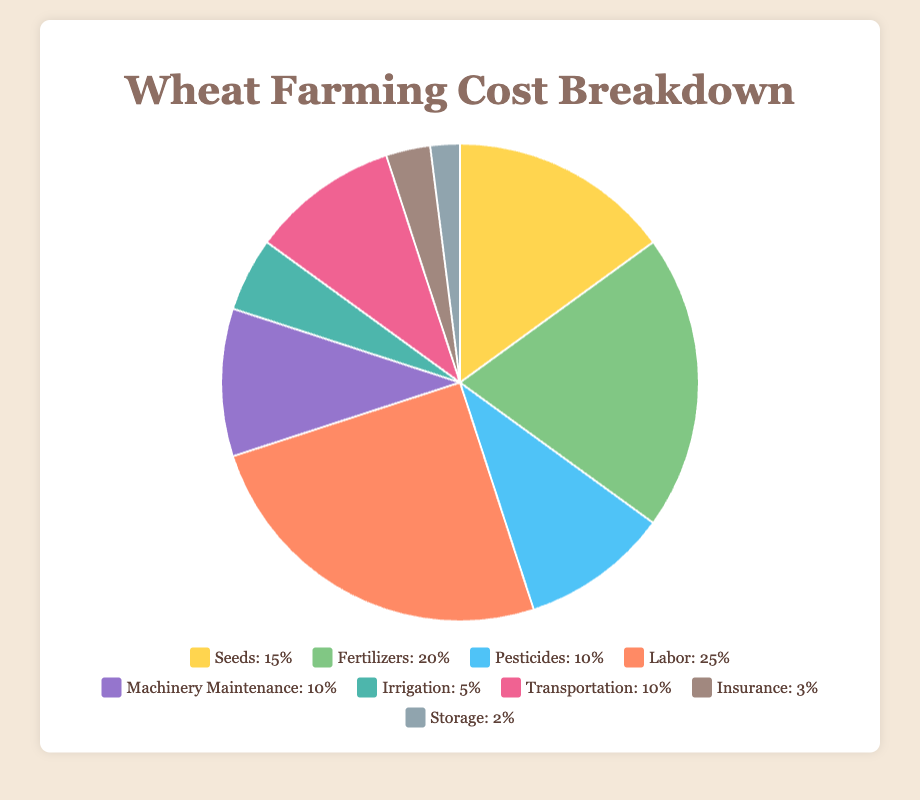What category has the highest cost percentage in wheat farming? The labor category has the highest cost percentage. By looking at the pie chart and the legend, labor contributes 25% to the total costs.
Answer: Labor What is the combined cost percentage of seeds and fertilizers? Adding the cost percentages of seeds (15%) and fertilizers (20%), you get 15% + 20% = 35%.
Answer: 35% Which costs more, irrigation or pesticides, and by how much? Pesticides cost more. Pesticides are at 10%, and irrigation is at 5%. The difference is 10% - 5% = 5%.
Answer: Pesticides cost 5% more What is the total percentage of costs covered by machinery maintenance, transportation, and insurance? Adding the percentages for machinery maintenance (10%), transportation (10%), and insurance (3%), the total is 10% + 10% + 3% = 23%.
Answer: 23% Which category has the smallest cost percentage and what is it? Storage has the smallest cost percentage. By looking at the chart and legend, storage has a cost percentage of 2%.
Answer: Storage, 2% Out of seeds, fertilizers, and irrigation, which category costs the least? Irrigation costs the least among the three categories. The chart shows irrigation at 5%, while seeds are 15% and fertilizers are 20%.
Answer: Irrigation What is the difference in cost percentage between transportation and storage? Transportation is at 10% and storage at 2%. The difference is 10% - 2% = 8%.
Answer: 8% What is the average cost percentage of fertilizers, pesticides, and labor? Adding the percentages of fertilizers (20%), pesticides (10%), and labor (25%) gives 20% + 10% + 25% = 55%. Dividing by 3, the average is 55% / 3 ≈ 18.33%.
Answer: 18.33% Compare the cost percentages of seeds and machinery maintenance. Which is higher? Seeds are at 15% and machinery maintenance is at 10%. Seeds have a higher cost percentage.
Answer: Seeds Calculate the excess cost percentage of labor compared to insurance and storage combined. Labor is at 25%, while insurance (3%) and storage (2%) combined is 3% + 2% = 5%. The excess is 25% - 5% = 20%.
Answer: 20% 